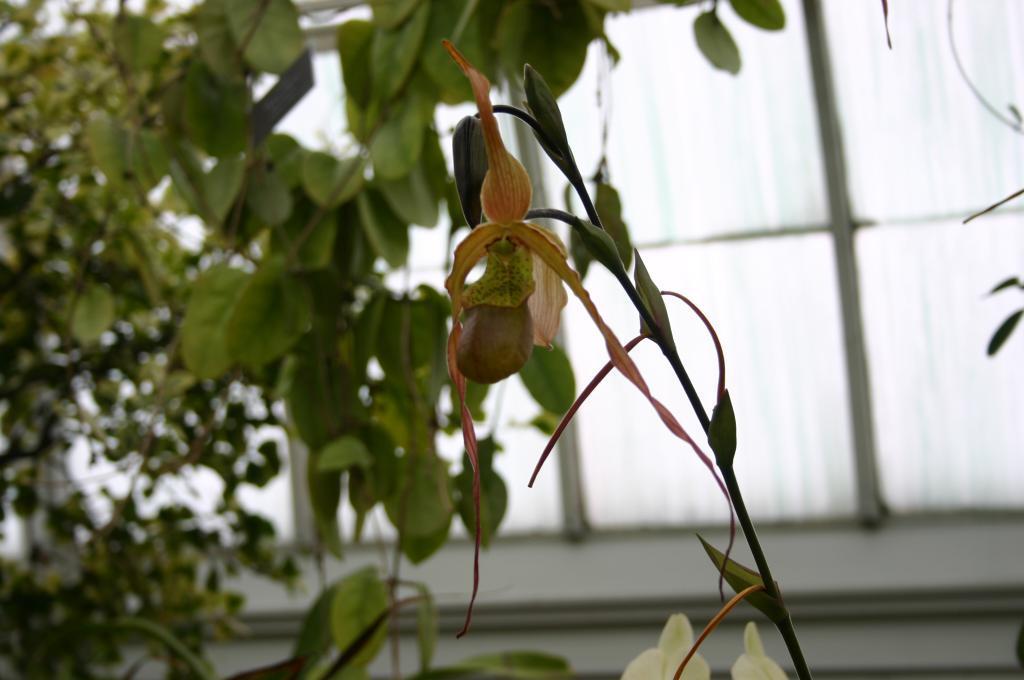How would you summarize this image in a sentence or two? In this image in the front there is seed on the plant and in the background there is a plant and there is a window. 